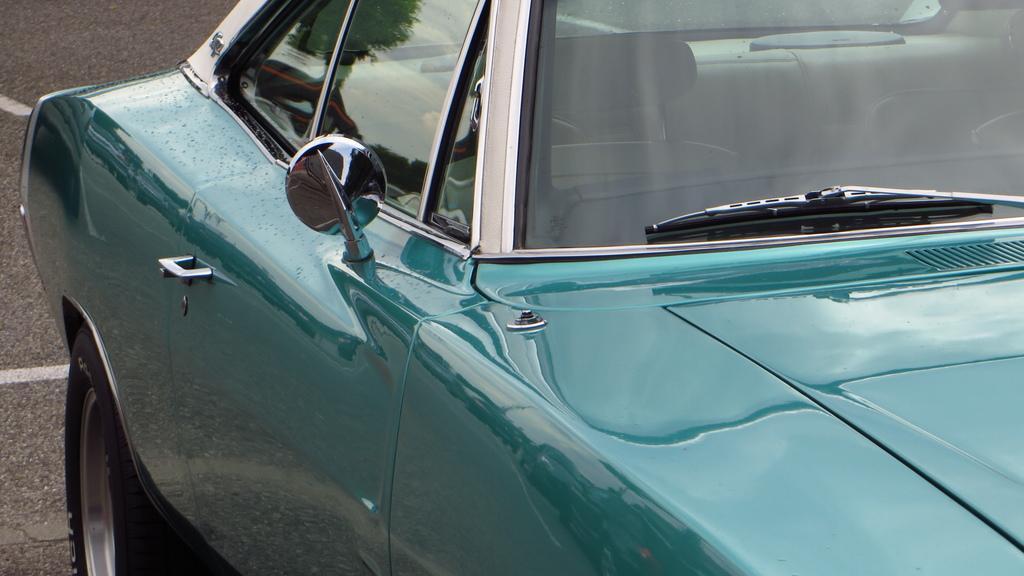Can you describe this image briefly? In this picture we can see a vehicle and in the background we can see the road. 